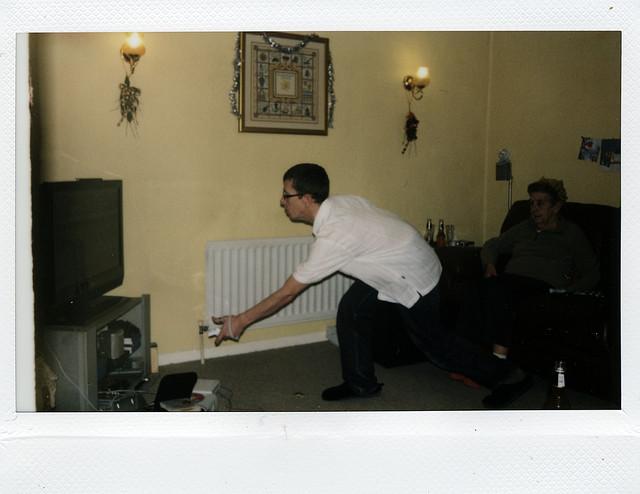What is being shown on the screen in front of the man?
Be succinct. Game. What room of the house is this?
Be succinct. Living room. How many people are in the picture?
Concise answer only. 2. Are the lights on?
Short answer required. Yes. What game are these people playing?
Answer briefly. Wii. 